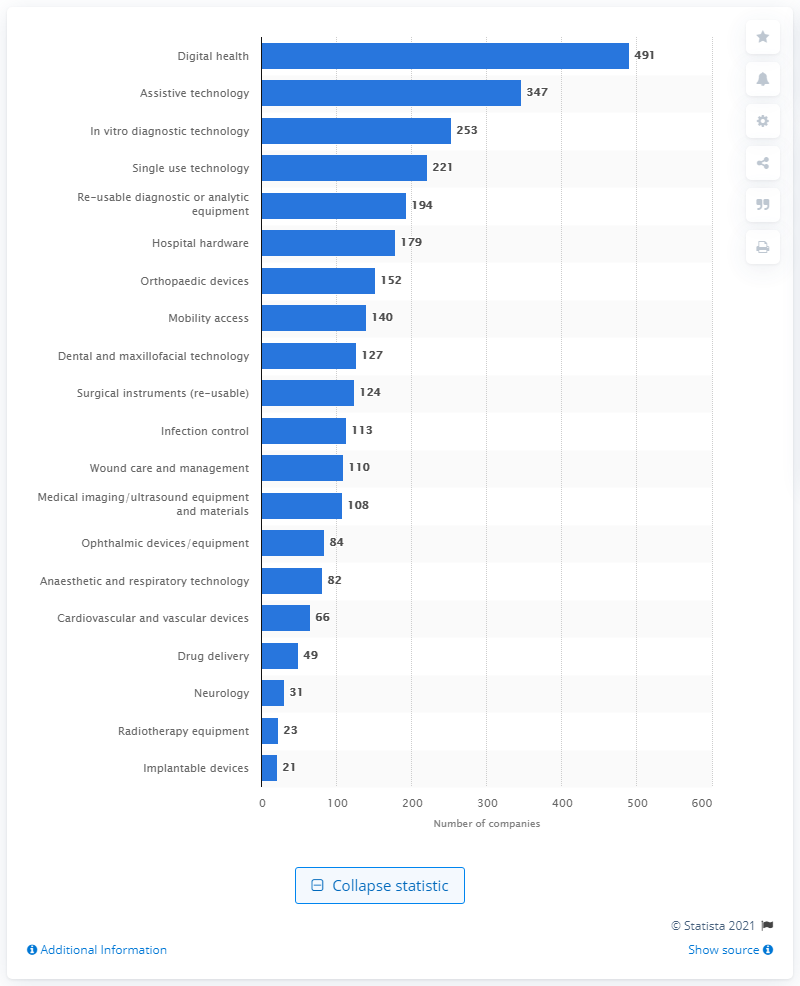Outline some significant characteristics in this image. There were 491 companies in the digital health segment in 2017. In 2017, the assistive technology segment had 347 companies. There were 21 implant devices in 2017. 